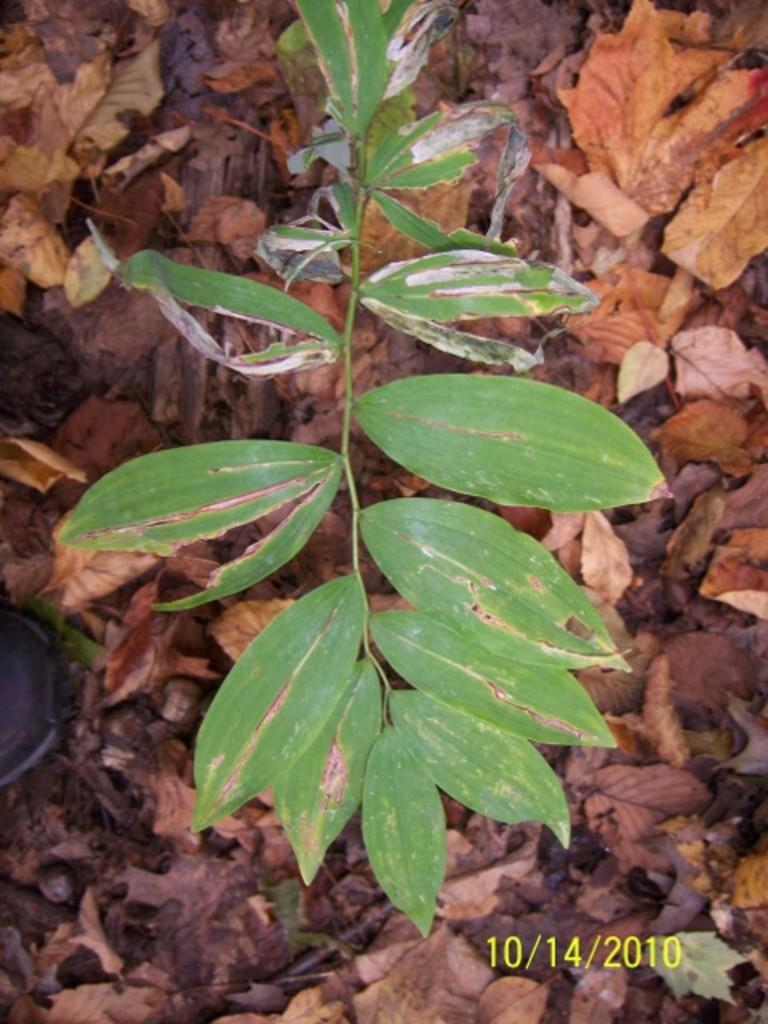What is located in the foreground of the image? There is a leaf in the foreground of the image. What can be seen in the background of the image? There are dry leaves in the background of the image. Is there a bridge made of waste material in the image? There is no bridge or waste material present in the image; it only features leaves in the foreground and background. 